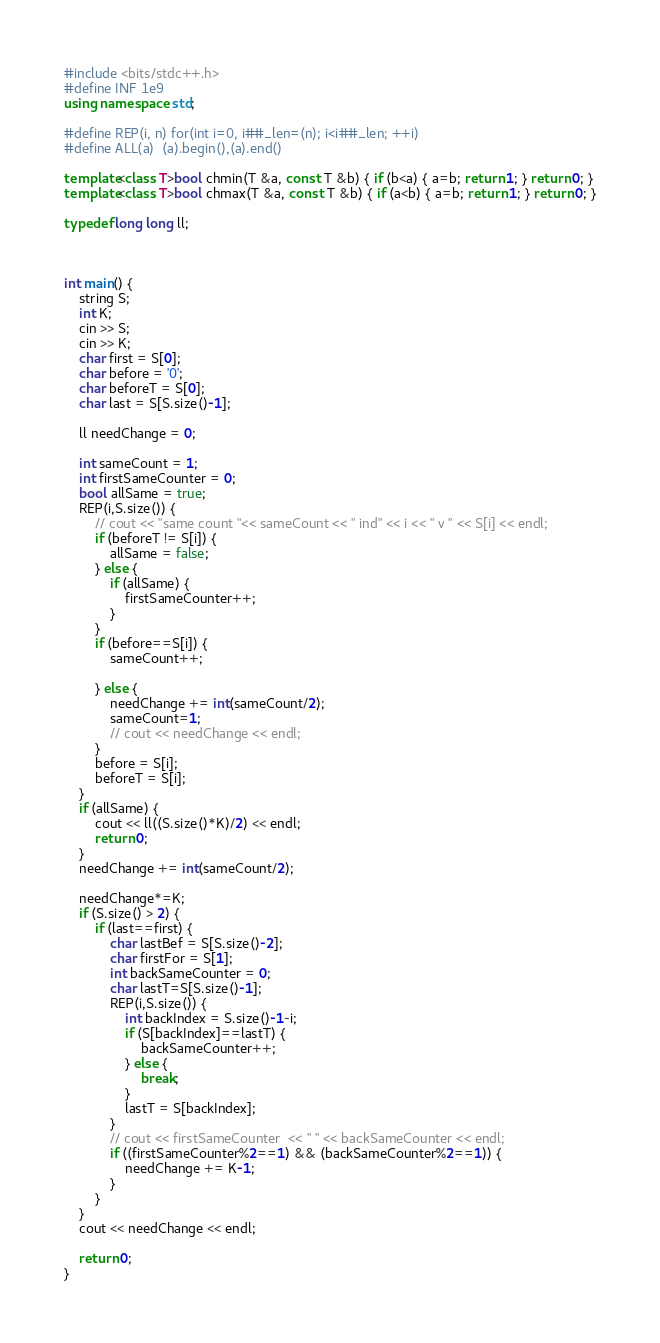Convert code to text. <code><loc_0><loc_0><loc_500><loc_500><_C++_>#include <bits/stdc++.h>
#define INF 1e9
using namespace std;

#define REP(i, n) for(int i=0, i##_len=(n); i<i##_len; ++i)
#define ALL(a)  (a).begin(),(a).end()

template<class T>bool chmin(T &a, const T &b) { if (b<a) { a=b; return 1; } return 0; }
template<class T>bool chmax(T &a, const T &b) { if (a<b) { a=b; return 1; } return 0; }

typedef long long ll;



int main() {
    string S;
    int K;
    cin >> S;
    cin >> K;
    char first = S[0];
    char before = '0';
    char beforeT = S[0];
    char last = S[S.size()-1];

    ll needChange = 0;

    int sameCount = 1;
    int firstSameCounter = 0;
    bool allSame = true;
    REP(i,S.size()) {
        // cout << "same count "<< sameCount << " ind" << i << " v " << S[i] << endl;
        if (beforeT != S[i]) {
            allSame = false;
        } else {
            if (allSame) {
                firstSameCounter++;
            }
        }
        if (before==S[i]) {
            sameCount++;

        } else {
            needChange += int(sameCount/2);
            sameCount=1;
            // cout << needChange << endl;
        }
        before = S[i];
        beforeT = S[i];
    }
    if (allSame) {
        cout << ll((S.size()*K)/2) << endl;
        return 0;
    }
    needChange += int(sameCount/2);

    needChange*=K;
    if (S.size() > 2) {
        if (last==first) {
            char lastBef = S[S.size()-2];
            char firstFor = S[1];
            int backSameCounter = 0;
            char lastT=S[S.size()-1];
            REP(i,S.size()) {
                int backIndex = S.size()-1-i;
                if (S[backIndex]==lastT) {
                    backSameCounter++;
                } else {
                    break;
                }
                lastT = S[backIndex];
            }
            // cout << firstSameCounter  << " " << backSameCounter << endl;
            if ((firstSameCounter%2==1) && (backSameCounter%2==1)) {
                needChange += K-1;
            }
        }
    }
    cout << needChange << endl;

    return 0;
}
</code> 